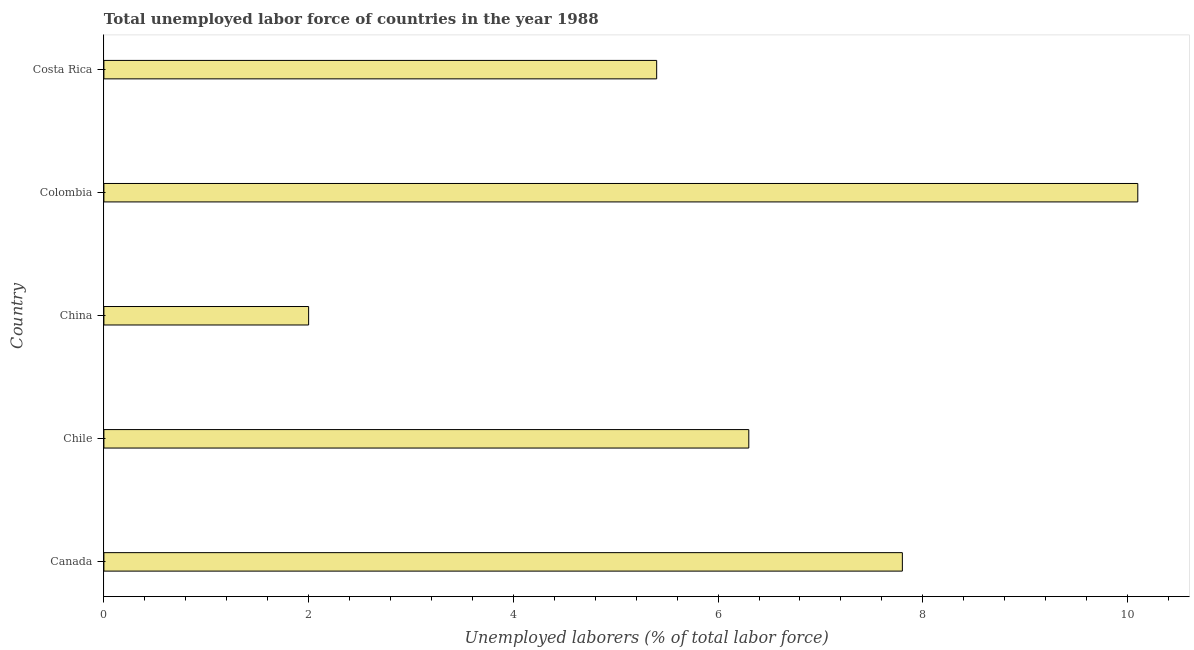What is the title of the graph?
Give a very brief answer. Total unemployed labor force of countries in the year 1988. What is the label or title of the X-axis?
Make the answer very short. Unemployed laborers (% of total labor force). What is the label or title of the Y-axis?
Your answer should be compact. Country. What is the total unemployed labour force in Colombia?
Make the answer very short. 10.1. Across all countries, what is the maximum total unemployed labour force?
Provide a short and direct response. 10.1. In which country was the total unemployed labour force maximum?
Offer a terse response. Colombia. What is the sum of the total unemployed labour force?
Make the answer very short. 31.6. What is the average total unemployed labour force per country?
Your answer should be very brief. 6.32. What is the median total unemployed labour force?
Offer a very short reply. 6.3. In how many countries, is the total unemployed labour force greater than 1.6 %?
Ensure brevity in your answer.  5. What is the ratio of the total unemployed labour force in Chile to that in China?
Offer a very short reply. 3.15. Is the total unemployed labour force in Canada less than that in Colombia?
Make the answer very short. Yes. In how many countries, is the total unemployed labour force greater than the average total unemployed labour force taken over all countries?
Your answer should be compact. 2. What is the difference between two consecutive major ticks on the X-axis?
Your answer should be very brief. 2. What is the Unemployed laborers (% of total labor force) in Canada?
Provide a succinct answer. 7.8. What is the Unemployed laborers (% of total labor force) in Chile?
Make the answer very short. 6.3. What is the Unemployed laborers (% of total labor force) in China?
Ensure brevity in your answer.  2. What is the Unemployed laborers (% of total labor force) of Colombia?
Your answer should be very brief. 10.1. What is the Unemployed laborers (% of total labor force) in Costa Rica?
Offer a terse response. 5.4. What is the difference between the Unemployed laborers (% of total labor force) in Canada and China?
Provide a succinct answer. 5.8. What is the difference between the Unemployed laborers (% of total labor force) in Canada and Colombia?
Ensure brevity in your answer.  -2.3. What is the difference between the Unemployed laborers (% of total labor force) in Chile and China?
Offer a terse response. 4.3. What is the difference between the Unemployed laborers (% of total labor force) in Chile and Colombia?
Your answer should be very brief. -3.8. What is the ratio of the Unemployed laborers (% of total labor force) in Canada to that in Chile?
Offer a terse response. 1.24. What is the ratio of the Unemployed laborers (% of total labor force) in Canada to that in China?
Provide a succinct answer. 3.9. What is the ratio of the Unemployed laborers (% of total labor force) in Canada to that in Colombia?
Provide a short and direct response. 0.77. What is the ratio of the Unemployed laborers (% of total labor force) in Canada to that in Costa Rica?
Offer a terse response. 1.44. What is the ratio of the Unemployed laborers (% of total labor force) in Chile to that in China?
Your answer should be very brief. 3.15. What is the ratio of the Unemployed laborers (% of total labor force) in Chile to that in Colombia?
Your response must be concise. 0.62. What is the ratio of the Unemployed laborers (% of total labor force) in Chile to that in Costa Rica?
Provide a short and direct response. 1.17. What is the ratio of the Unemployed laborers (% of total labor force) in China to that in Colombia?
Offer a very short reply. 0.2. What is the ratio of the Unemployed laborers (% of total labor force) in China to that in Costa Rica?
Keep it short and to the point. 0.37. What is the ratio of the Unemployed laborers (% of total labor force) in Colombia to that in Costa Rica?
Keep it short and to the point. 1.87. 